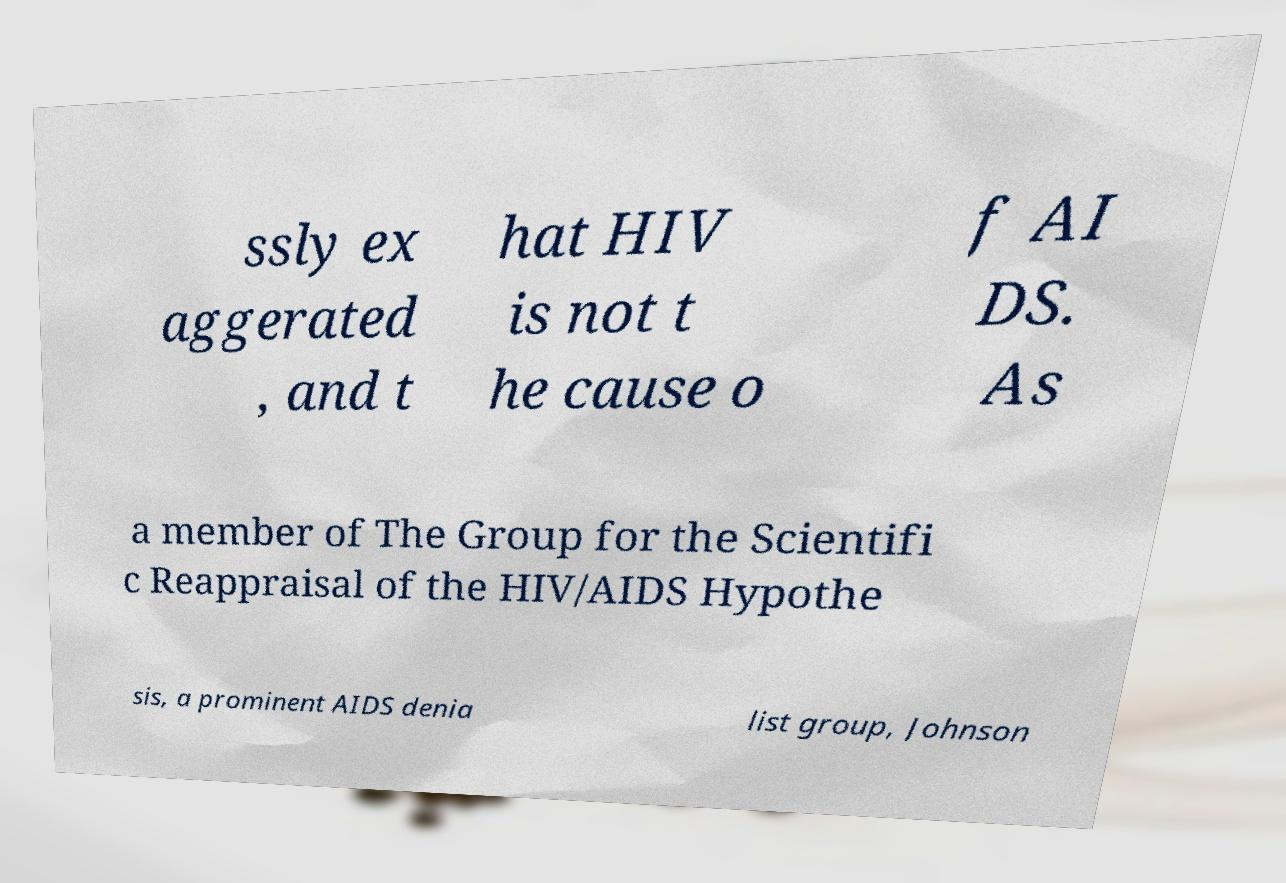I need the written content from this picture converted into text. Can you do that? ssly ex aggerated , and t hat HIV is not t he cause o f AI DS. As a member of The Group for the Scientifi c Reappraisal of the HIV/AIDS Hypothe sis, a prominent AIDS denia list group, Johnson 